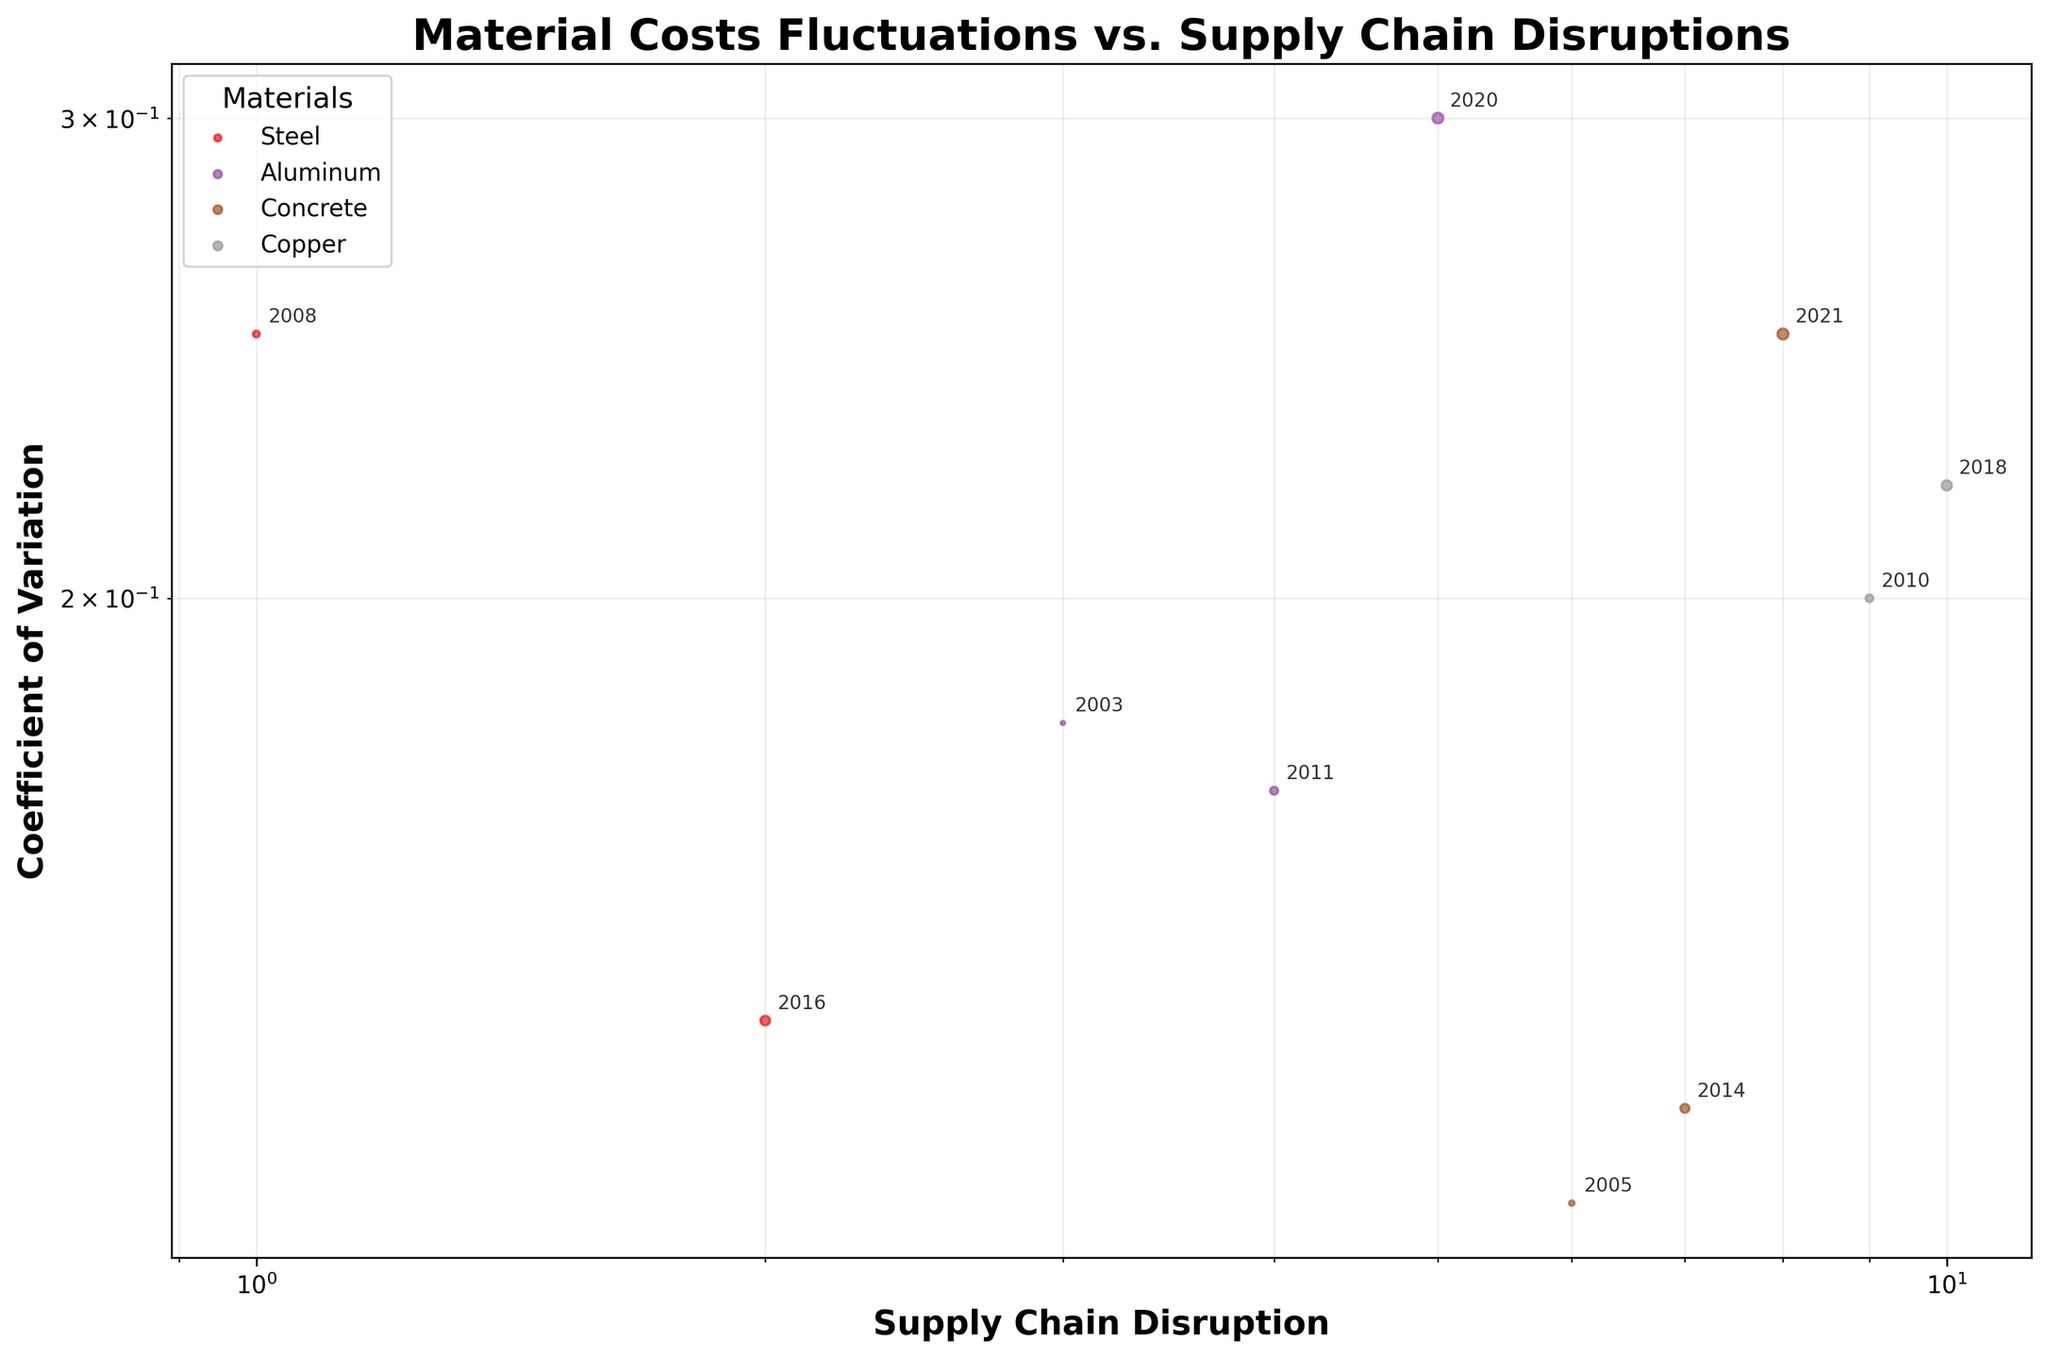What's the title of the plot? The title of the plot is usually found at the top and provides an overview of what the plot represents. Here, the title is in bold and easy to spot at the top of the figure.
Answer: Material Costs Fluctuations vs. Supply Chain Disruptions What are the axes labels? The axes labels describe what each axis represents. The x-axis label is at the bottom of the plot, and the y-axis label is on the left side. Both are in bold font for clarity.
Answer: Supply Chain Disruption (x-axis), Coefficient of Variation (y-axis) Which material has the highest coefficient of variation in the figure? By visual inspection of the scatter plot, find the highest point on the y-axis and check the color/label of the corresponding material.
Answer: Aluminum (2020) What supply chain disruption is associated with the highest coefficient of variation for Concrete? First, identify the points corresponding to Concrete, then find the point that has the highest value on the y-axis (Coefficient of Variation) among Concrete points. Check the disruption label of this point.
Answer: Global Shipping Crisis (2021) How many data points are associated with Steel? Identify the distinct colors or markers corresponding to Steel by referring to the legend, then count the number of such points in the scatter plot.
Answer: 3 Which year had the lowest coefficient of variation for Aluminum, and what was the corresponding supply chain disruption? Identify the points corresponding to Aluminum, then find the lowest point on the y-axis among them. Check the year and disruption label of this point.
Answer: 2011, Japan Earthquake and Tsunami Compare the coefficient of variation of Steel during the Dot-com Bubble Burst and Global Financial Crisis. Which event had a higher coefficient? Find the Steel points labeled with these disruptions, then compare their y-axis positions to determine which is higher.
Answer: Global Financial Crisis What's the general trend observed between the coefficient of variation and the global supply chain disruptions over the years? Look for overall patterns or trends in the scatter plot, considering both the x-axis and y-axis. Evaluate if there is any perceptible trend in the data points over the years.
Answer: Increase in variation over recent years What's the average coefficient of variation for Concrete across all disruptions? Identify all the points corresponding to Concrete and sum their coefficients of variation, then divide by the number of Concrete points to get the average.
Answer: (0.12 + 0.13 + 0.25) / 3 = 0.167 Is there any visible cluster of data points for a particular material? If yes, which material and around which years? Check the scatter plot for any group of data points that are closely packed together. Identify the material and the approximate years this cluster corresponds to.
Answer: No distinct cluster visible 